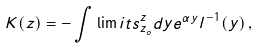<formula> <loc_0><loc_0><loc_500><loc_500>K ( z ) = - \int \lim i t s _ { z _ { o } } ^ { z } d y e ^ { \alpha y } l ^ { - 1 } ( y ) \, ,</formula> 